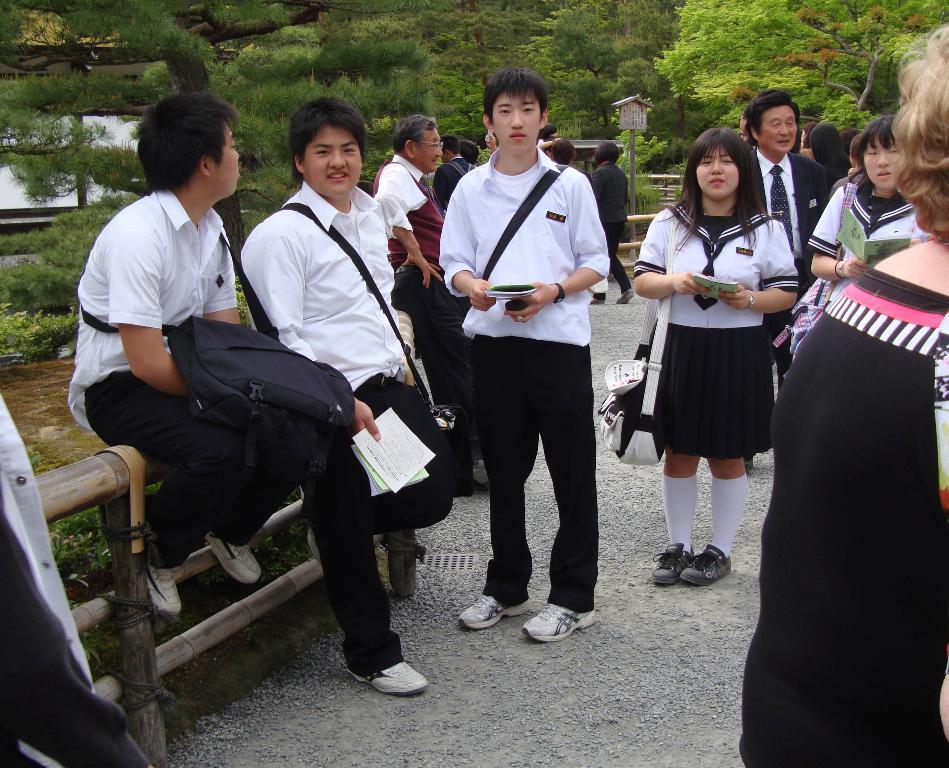How would you summarize this image in a sentence or two? Here a man is sitting on the wooden fencing, he wore white color shirt, black color trouser. On the right side a girl is standing and looking at this side. There are trees at the backside of an image. 